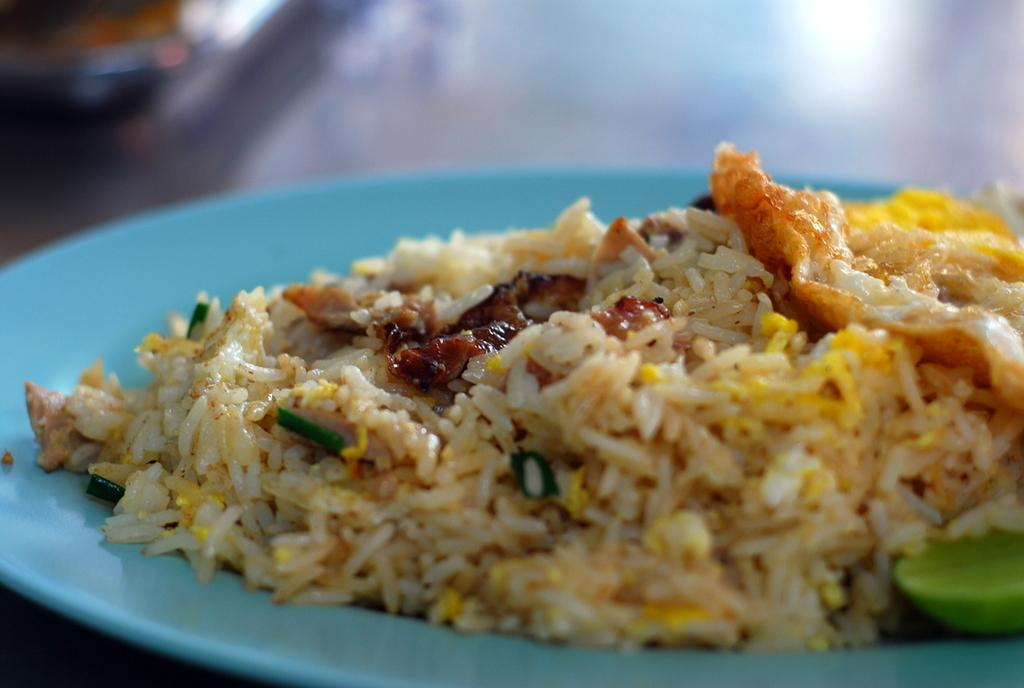What is placed on the plate in the image? There is a plate with food items in the image. Can you describe the food items on the plate? Unfortunately, the specific food items cannot be determined from the provided facts. What might someone be about to do with the plate and food items? Someone might be about to eat the food items on the plate. What type of music is being played in the background of the image? There is no information about music or any background sounds in the provided facts, so it cannot be determined from the image. 